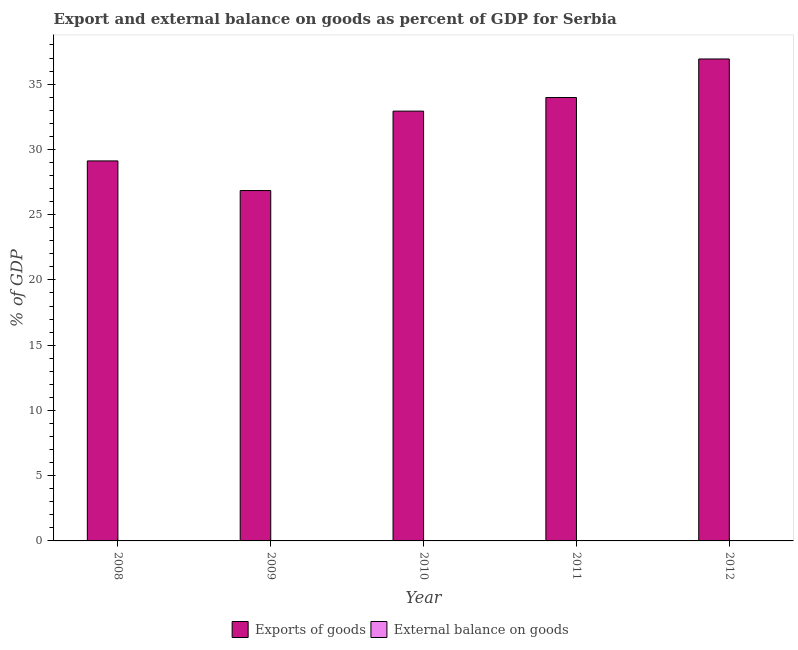How many different coloured bars are there?
Provide a succinct answer. 1. Are the number of bars per tick equal to the number of legend labels?
Give a very brief answer. No. Are the number of bars on each tick of the X-axis equal?
Your response must be concise. Yes. How many bars are there on the 2nd tick from the right?
Your answer should be compact. 1. What is the label of the 1st group of bars from the left?
Provide a succinct answer. 2008. Across all years, what is the maximum export of goods as percentage of gdp?
Provide a short and direct response. 36.93. Across all years, what is the minimum export of goods as percentage of gdp?
Give a very brief answer. 26.85. In which year was the export of goods as percentage of gdp maximum?
Ensure brevity in your answer.  2012. What is the total export of goods as percentage of gdp in the graph?
Your answer should be compact. 159.8. What is the difference between the export of goods as percentage of gdp in 2008 and that in 2009?
Offer a very short reply. 2.27. What is the difference between the export of goods as percentage of gdp in 2012 and the external balance on goods as percentage of gdp in 2009?
Provide a short and direct response. 10.08. In the year 2008, what is the difference between the export of goods as percentage of gdp and external balance on goods as percentage of gdp?
Make the answer very short. 0. What is the ratio of the export of goods as percentage of gdp in 2008 to that in 2011?
Keep it short and to the point. 0.86. Is the export of goods as percentage of gdp in 2009 less than that in 2011?
Offer a terse response. Yes. Is the difference between the export of goods as percentage of gdp in 2010 and 2012 greater than the difference between the external balance on goods as percentage of gdp in 2010 and 2012?
Provide a succinct answer. No. What is the difference between the highest and the second highest export of goods as percentage of gdp?
Provide a succinct answer. 2.95. What is the difference between the highest and the lowest export of goods as percentage of gdp?
Ensure brevity in your answer.  10.08. In how many years, is the external balance on goods as percentage of gdp greater than the average external balance on goods as percentage of gdp taken over all years?
Your answer should be compact. 0. How many bars are there?
Your answer should be compact. 5. How many years are there in the graph?
Provide a succinct answer. 5. What is the difference between two consecutive major ticks on the Y-axis?
Offer a very short reply. 5. Does the graph contain any zero values?
Offer a very short reply. Yes. How many legend labels are there?
Give a very brief answer. 2. What is the title of the graph?
Your response must be concise. Export and external balance on goods as percent of GDP for Serbia. Does "Unregistered firms" appear as one of the legend labels in the graph?
Your answer should be compact. No. What is the label or title of the X-axis?
Your answer should be compact. Year. What is the label or title of the Y-axis?
Keep it short and to the point. % of GDP. What is the % of GDP in Exports of goods in 2008?
Offer a terse response. 29.12. What is the % of GDP of External balance on goods in 2008?
Offer a very short reply. 0. What is the % of GDP in Exports of goods in 2009?
Provide a short and direct response. 26.85. What is the % of GDP in External balance on goods in 2009?
Give a very brief answer. 0. What is the % of GDP in Exports of goods in 2010?
Your response must be concise. 32.93. What is the % of GDP in External balance on goods in 2010?
Give a very brief answer. 0. What is the % of GDP in Exports of goods in 2011?
Your answer should be very brief. 33.98. What is the % of GDP in External balance on goods in 2011?
Your response must be concise. 0. What is the % of GDP in Exports of goods in 2012?
Your response must be concise. 36.93. What is the % of GDP in External balance on goods in 2012?
Your answer should be compact. 0. Across all years, what is the maximum % of GDP of Exports of goods?
Give a very brief answer. 36.93. Across all years, what is the minimum % of GDP in Exports of goods?
Offer a terse response. 26.85. What is the total % of GDP of Exports of goods in the graph?
Provide a short and direct response. 159.8. What is the difference between the % of GDP of Exports of goods in 2008 and that in 2009?
Keep it short and to the point. 2.27. What is the difference between the % of GDP of Exports of goods in 2008 and that in 2010?
Ensure brevity in your answer.  -3.82. What is the difference between the % of GDP of Exports of goods in 2008 and that in 2011?
Your answer should be compact. -4.86. What is the difference between the % of GDP of Exports of goods in 2008 and that in 2012?
Keep it short and to the point. -7.81. What is the difference between the % of GDP of Exports of goods in 2009 and that in 2010?
Keep it short and to the point. -6.09. What is the difference between the % of GDP of Exports of goods in 2009 and that in 2011?
Your answer should be very brief. -7.13. What is the difference between the % of GDP of Exports of goods in 2009 and that in 2012?
Provide a short and direct response. -10.08. What is the difference between the % of GDP in Exports of goods in 2010 and that in 2011?
Give a very brief answer. -1.04. What is the difference between the % of GDP of Exports of goods in 2010 and that in 2012?
Ensure brevity in your answer.  -4. What is the difference between the % of GDP in Exports of goods in 2011 and that in 2012?
Provide a succinct answer. -2.95. What is the average % of GDP in Exports of goods per year?
Your answer should be very brief. 31.96. What is the average % of GDP of External balance on goods per year?
Give a very brief answer. 0. What is the ratio of the % of GDP of Exports of goods in 2008 to that in 2009?
Offer a very short reply. 1.08. What is the ratio of the % of GDP of Exports of goods in 2008 to that in 2010?
Make the answer very short. 0.88. What is the ratio of the % of GDP of Exports of goods in 2008 to that in 2011?
Provide a short and direct response. 0.86. What is the ratio of the % of GDP of Exports of goods in 2008 to that in 2012?
Give a very brief answer. 0.79. What is the ratio of the % of GDP in Exports of goods in 2009 to that in 2010?
Provide a succinct answer. 0.82. What is the ratio of the % of GDP in Exports of goods in 2009 to that in 2011?
Your answer should be very brief. 0.79. What is the ratio of the % of GDP in Exports of goods in 2009 to that in 2012?
Make the answer very short. 0.73. What is the ratio of the % of GDP of Exports of goods in 2010 to that in 2011?
Provide a short and direct response. 0.97. What is the ratio of the % of GDP of Exports of goods in 2010 to that in 2012?
Your answer should be compact. 0.89. What is the ratio of the % of GDP in Exports of goods in 2011 to that in 2012?
Make the answer very short. 0.92. What is the difference between the highest and the second highest % of GDP of Exports of goods?
Make the answer very short. 2.95. What is the difference between the highest and the lowest % of GDP of Exports of goods?
Offer a very short reply. 10.08. 